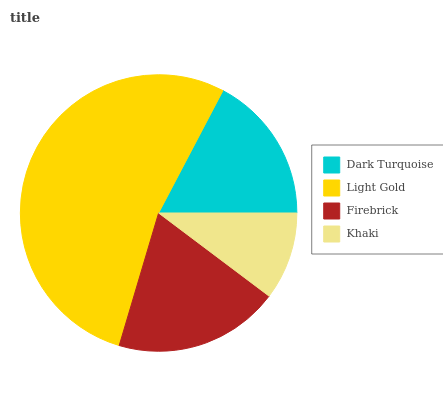Is Khaki the minimum?
Answer yes or no. Yes. Is Light Gold the maximum?
Answer yes or no. Yes. Is Firebrick the minimum?
Answer yes or no. No. Is Firebrick the maximum?
Answer yes or no. No. Is Light Gold greater than Firebrick?
Answer yes or no. Yes. Is Firebrick less than Light Gold?
Answer yes or no. Yes. Is Firebrick greater than Light Gold?
Answer yes or no. No. Is Light Gold less than Firebrick?
Answer yes or no. No. Is Firebrick the high median?
Answer yes or no. Yes. Is Dark Turquoise the low median?
Answer yes or no. Yes. Is Light Gold the high median?
Answer yes or no. No. Is Light Gold the low median?
Answer yes or no. No. 